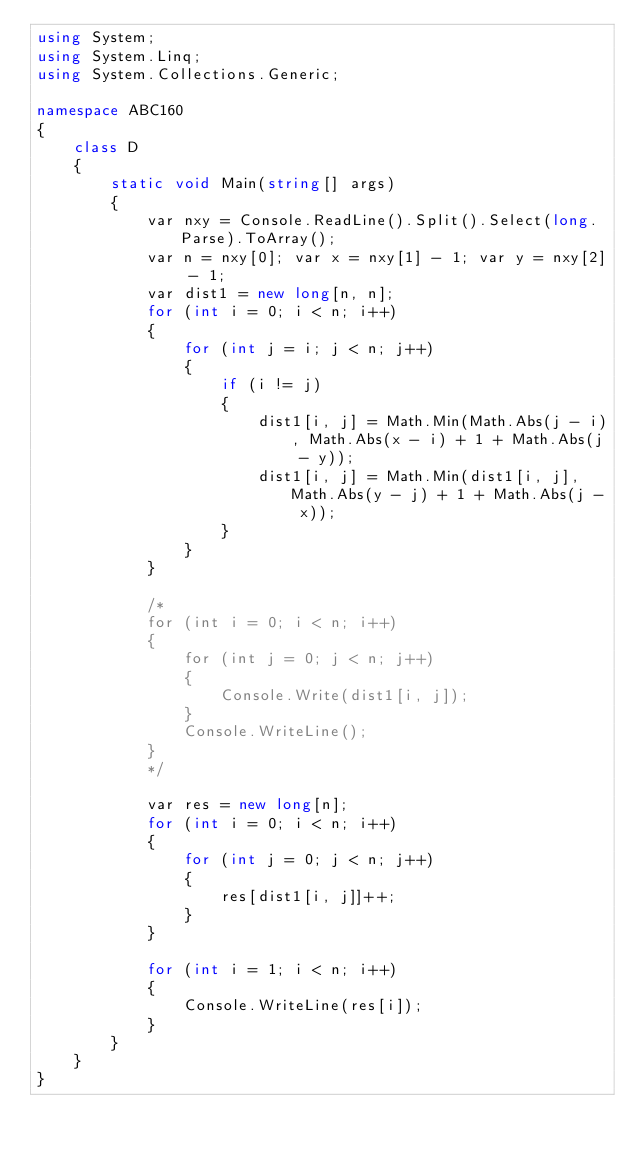Convert code to text. <code><loc_0><loc_0><loc_500><loc_500><_C#_>using System;
using System.Linq;
using System.Collections.Generic;

namespace ABC160
{
    class D
    {
        static void Main(string[] args)
        {
            var nxy = Console.ReadLine().Split().Select(long.Parse).ToArray();
            var n = nxy[0]; var x = nxy[1] - 1; var y = nxy[2] - 1;
            var dist1 = new long[n, n];
            for (int i = 0; i < n; i++)
            {
                for (int j = i; j < n; j++)
                {
                    if (i != j)
                    {
                        dist1[i, j] = Math.Min(Math.Abs(j - i), Math.Abs(x - i) + 1 + Math.Abs(j - y));
                        dist1[i, j] = Math.Min(dist1[i, j], Math.Abs(y - j) + 1 + Math.Abs(j - x));
                    }
                }
            }

            /*
            for (int i = 0; i < n; i++)
            {
                for (int j = 0; j < n; j++)
                {
                    Console.Write(dist1[i, j]);
                }
                Console.WriteLine();
            }
            */

            var res = new long[n];
            for (int i = 0; i < n; i++)
            {
                for (int j = 0; j < n; j++)
                {
                    res[dist1[i, j]]++;
                }
            }

            for (int i = 1; i < n; i++)
            {
                Console.WriteLine(res[i]);
            }
        }
    }
}
</code> 